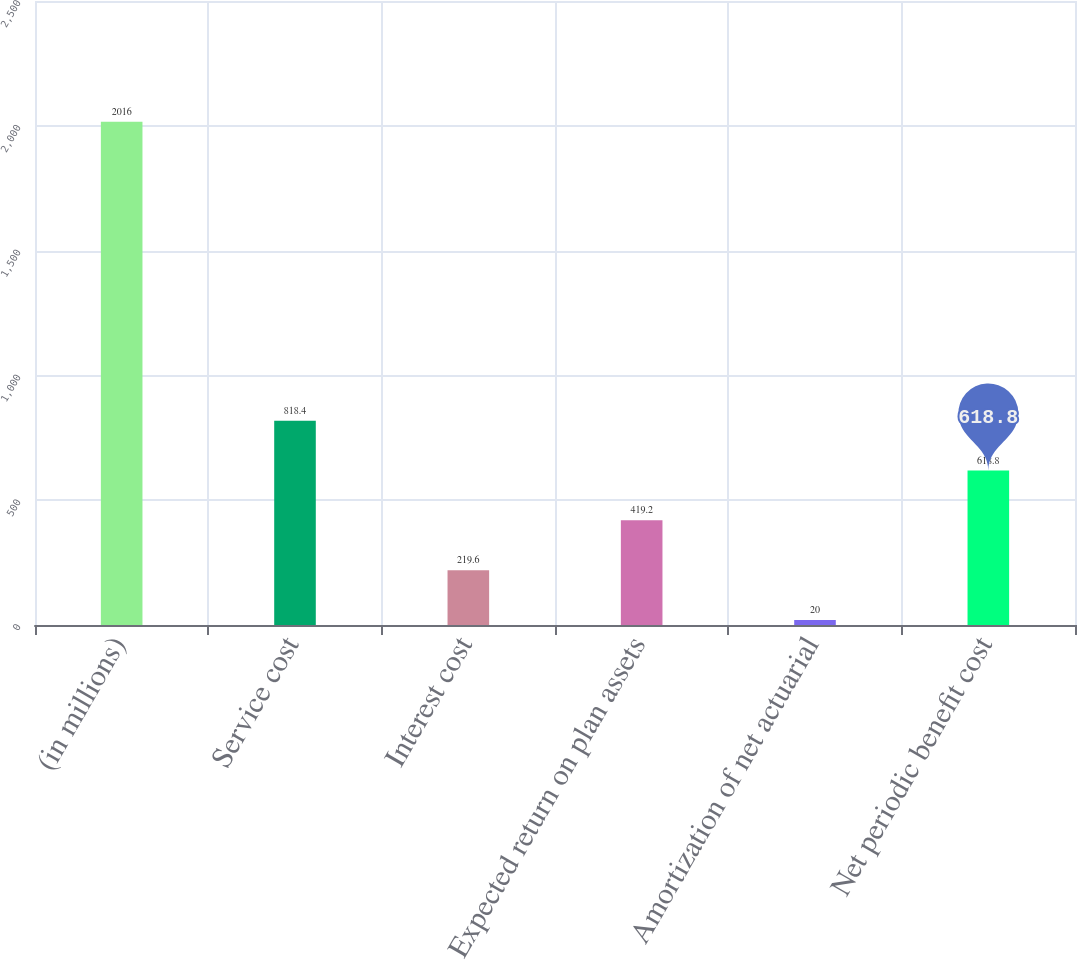Convert chart to OTSL. <chart><loc_0><loc_0><loc_500><loc_500><bar_chart><fcel>(in millions)<fcel>Service cost<fcel>Interest cost<fcel>Expected return on plan assets<fcel>Amortization of net actuarial<fcel>Net periodic benefit cost<nl><fcel>2016<fcel>818.4<fcel>219.6<fcel>419.2<fcel>20<fcel>618.8<nl></chart> 